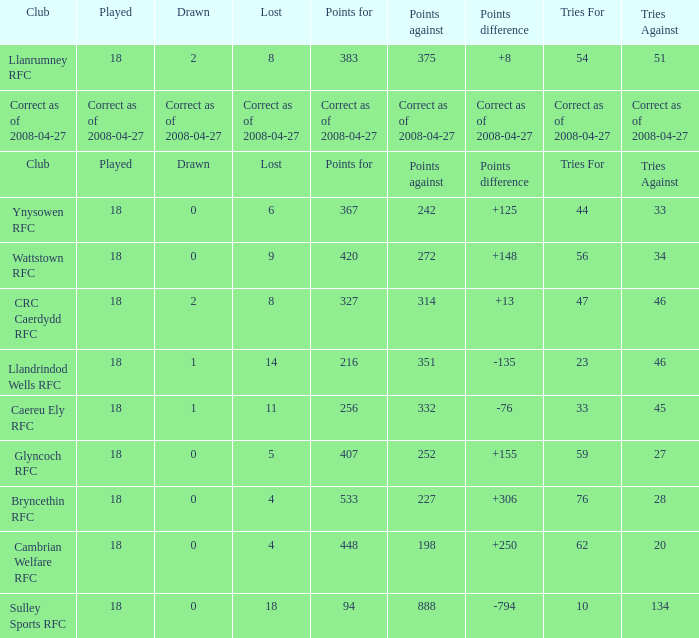What is the value for the item "Lost" when the value "Tries" is 47? 8.0. 